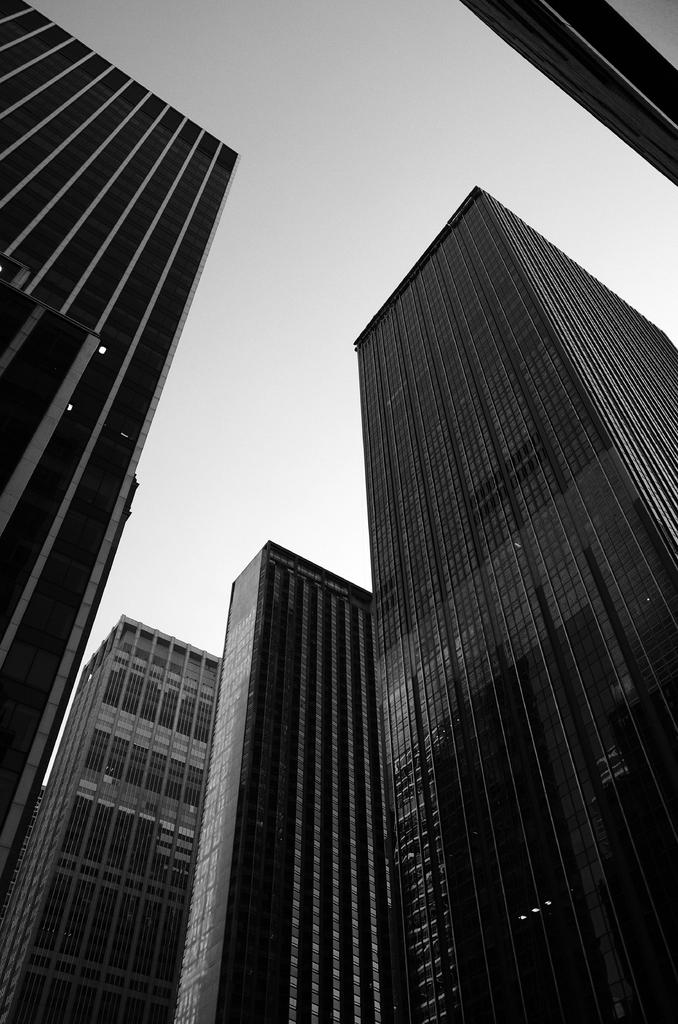What is the color scheme of the image? The image is black and white. What type of structures are present in the image? There are multistory buildings in the image. What is visible at the top of the image? The sky is visible at the top of the image. Can you see a church in the image? There is no church present in the image; it features multistory buildings. How many floors are there in the floor depicted in the image? There is no specific floor mentioned in the image, as it shows multistory buildings in general. 